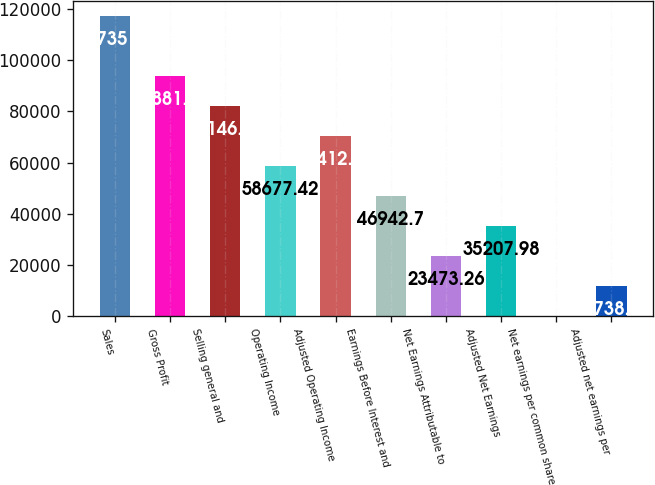<chart> <loc_0><loc_0><loc_500><loc_500><bar_chart><fcel>Sales<fcel>Gross Profit<fcel>Selling general and<fcel>Operating Income<fcel>Adjusted Operating Income<fcel>Earnings Before Interest and<fcel>Net Earnings Attributable to<fcel>Adjusted Net Earnings<fcel>Net earnings per common share<fcel>Adjusted net earnings per<nl><fcel>117351<fcel>93881.6<fcel>82146.9<fcel>58677.4<fcel>70412.1<fcel>46942.7<fcel>23473.3<fcel>35208<fcel>3.82<fcel>11738.5<nl></chart> 